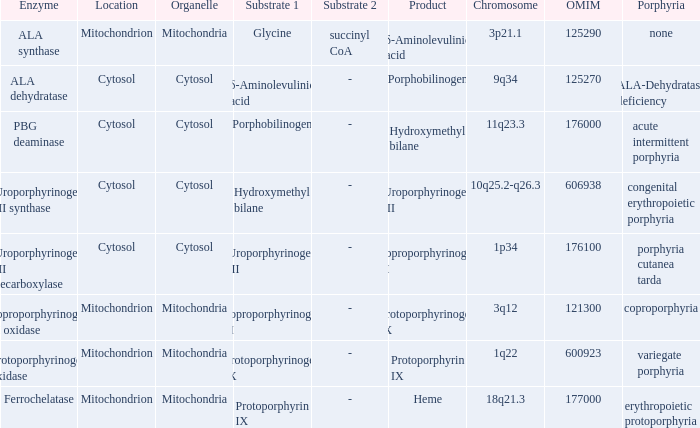Which substrate has an OMIM of 176000? Porphobilinogen. 